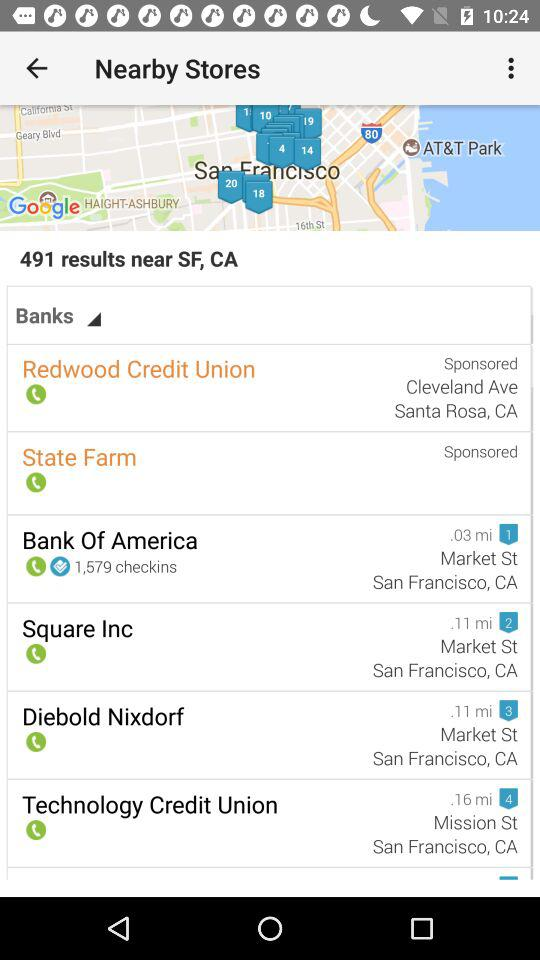How many results are shown for the search term Banks? 491 